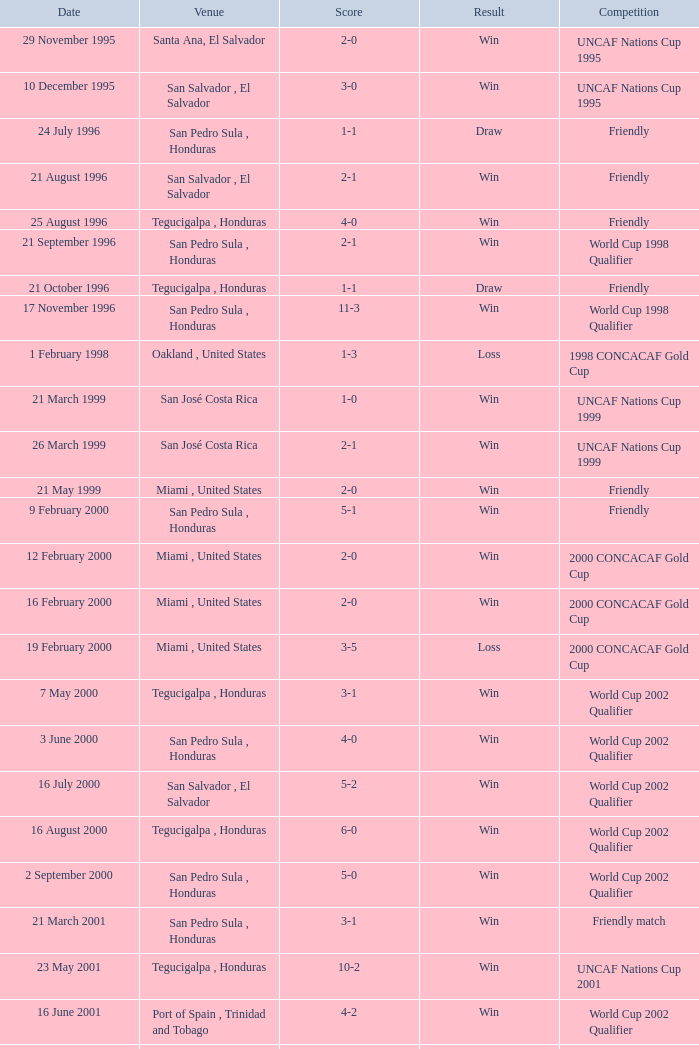What is the venue for the friendly competition and score of 4-0? Tegucigalpa , Honduras. 